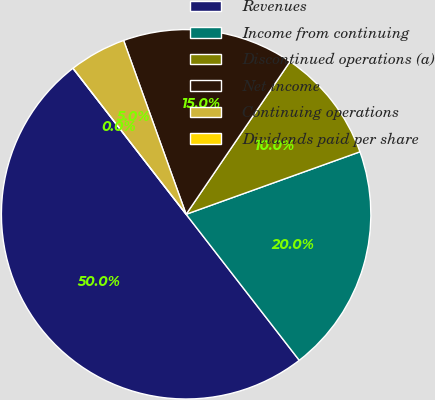Convert chart. <chart><loc_0><loc_0><loc_500><loc_500><pie_chart><fcel>Revenues<fcel>Income from continuing<fcel>Discontinued operations (a)<fcel>Net income<fcel>Continuing operations<fcel>Dividends paid per share<nl><fcel>50.0%<fcel>20.0%<fcel>10.0%<fcel>15.0%<fcel>5.0%<fcel>0.0%<nl></chart> 